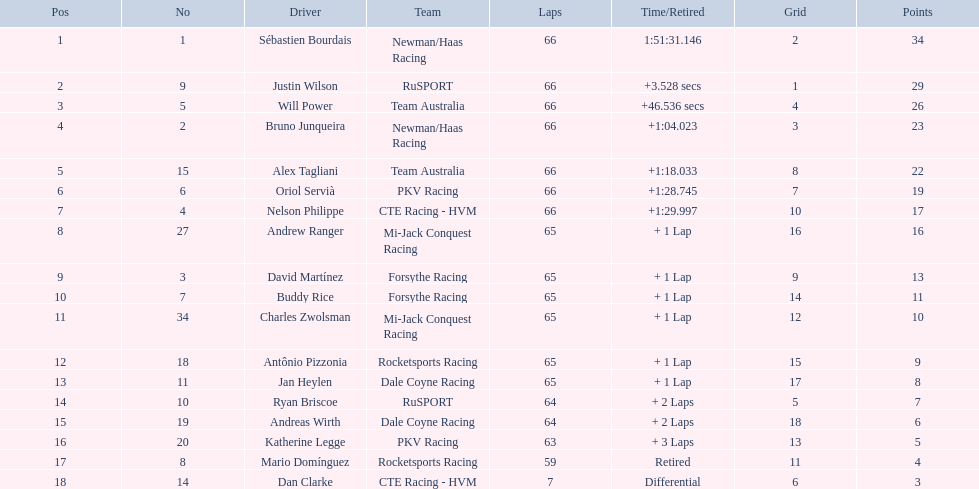What drivers initiated in the top 10? Sébastien Bourdais, Justin Wilson, Will Power, Bruno Junqueira, Alex Tagliani, Oriol Servià, Nelson Philippe, Ryan Briscoe, Dan Clarke. Which of those drivers completed all 66 laps? Sébastien Bourdais, Justin Wilson, Will Power, Bruno Junqueira, Alex Tagliani, Oriol Servià, Nelson Philippe. Who among these did not participate for team australia? Sébastien Bourdais, Justin Wilson, Bruno Junqueira, Oriol Servià, Nelson Philippe. Which of these drivers terminated more than a minute after the winner? Bruno Junqueira, Oriol Servià, Nelson Philippe. Which of these drivers had the highest car number? Oriol Servià. 